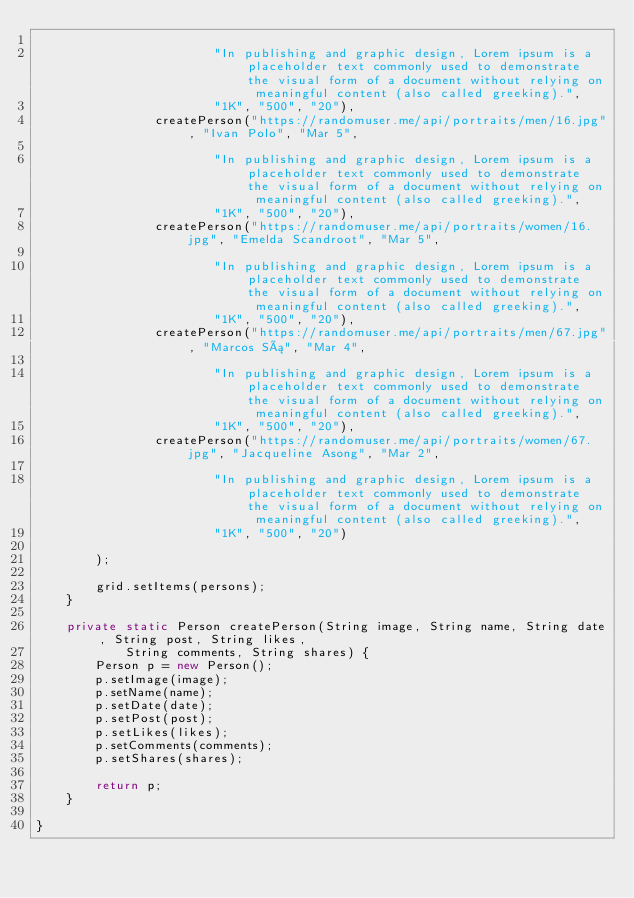<code> <loc_0><loc_0><loc_500><loc_500><_Java_>
                        "In publishing and graphic design, Lorem ipsum is a placeholder text commonly used to demonstrate the visual form of a document without relying on meaningful content (also called greeking).",
                        "1K", "500", "20"),
                createPerson("https://randomuser.me/api/portraits/men/16.jpg", "Ivan Polo", "Mar 5",

                        "In publishing and graphic design, Lorem ipsum is a placeholder text commonly used to demonstrate the visual form of a document without relying on meaningful content (also called greeking).",
                        "1K", "500", "20"),
                createPerson("https://randomuser.me/api/portraits/women/16.jpg", "Emelda Scandroot", "Mar 5",

                        "In publishing and graphic design, Lorem ipsum is a placeholder text commonly used to demonstrate the visual form of a document without relying on meaningful content (also called greeking).",
                        "1K", "500", "20"),
                createPerson("https://randomuser.me/api/portraits/men/67.jpg", "Marcos Sá", "Mar 4",

                        "In publishing and graphic design, Lorem ipsum is a placeholder text commonly used to demonstrate the visual form of a document without relying on meaningful content (also called greeking).",
                        "1K", "500", "20"),
                createPerson("https://randomuser.me/api/portraits/women/67.jpg", "Jacqueline Asong", "Mar 2",

                        "In publishing and graphic design, Lorem ipsum is a placeholder text commonly used to demonstrate the visual form of a document without relying on meaningful content (also called greeking).",
                        "1K", "500", "20")

        );

        grid.setItems(persons);
    }

    private static Person createPerson(String image, String name, String date, String post, String likes,
            String comments, String shares) {
        Person p = new Person();
        p.setImage(image);
        p.setName(name);
        p.setDate(date);
        p.setPost(post);
        p.setLikes(likes);
        p.setComments(comments);
        p.setShares(shares);

        return p;
    }

}
</code> 